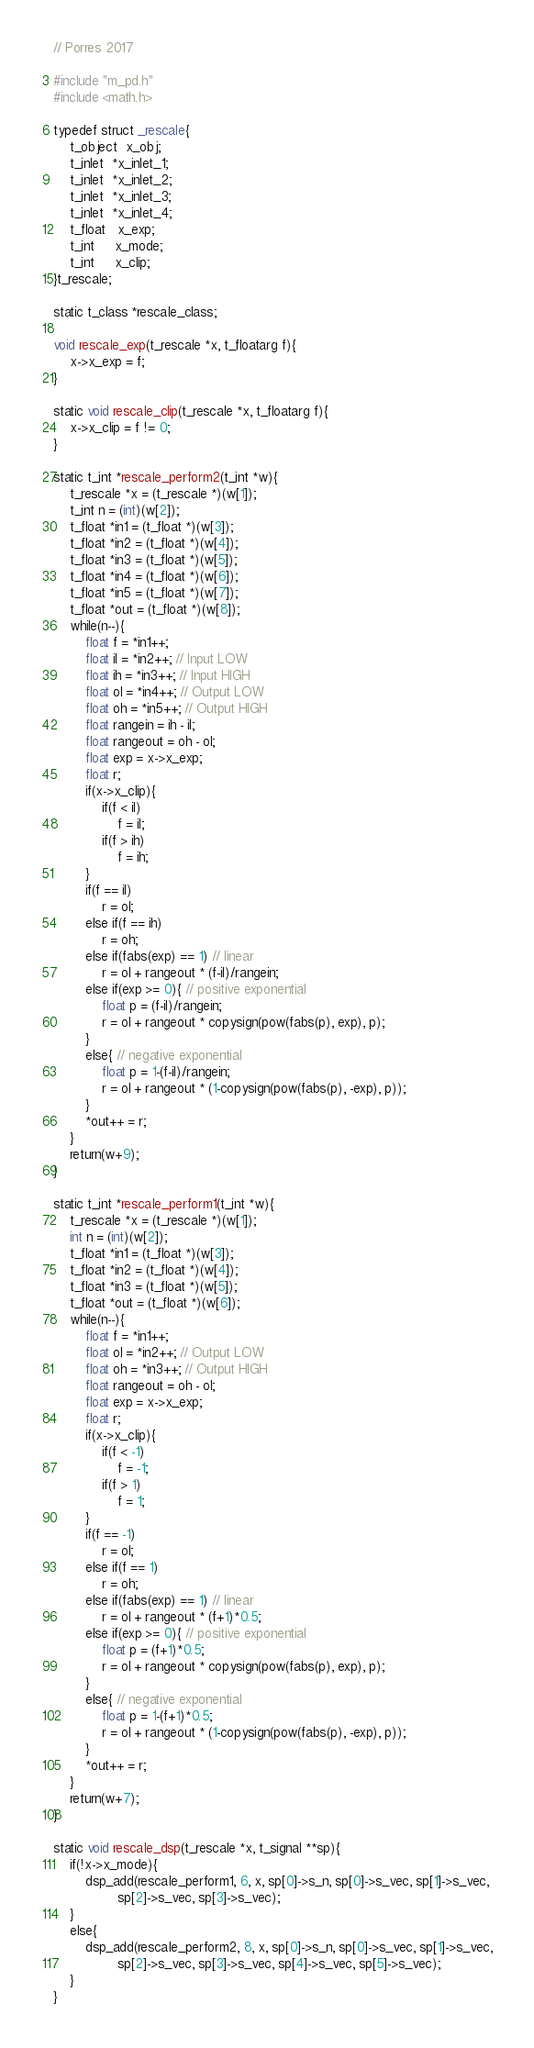Convert code to text. <code><loc_0><loc_0><loc_500><loc_500><_C_>// Porres 2017

#include "m_pd.h"
#include <math.h>

typedef struct _rescale{
    t_object  x_obj;
    t_inlet  *x_inlet_1;
    t_inlet  *x_inlet_2;
    t_inlet  *x_inlet_3;
    t_inlet  *x_inlet_4;
    t_float   x_exp;
    t_int     x_mode;
    t_int     x_clip;
}t_rescale;

static t_class *rescale_class;

void rescale_exp(t_rescale *x, t_floatarg f){
    x->x_exp = f;
}

static void rescale_clip(t_rescale *x, t_floatarg f){
    x->x_clip = f != 0;
}

static t_int *rescale_perform2(t_int *w){
    t_rescale *x = (t_rescale *)(w[1]);
    t_int n = (int)(w[2]);
    t_float *in1 = (t_float *)(w[3]);
    t_float *in2 = (t_float *)(w[4]);
    t_float *in3 = (t_float *)(w[5]);
    t_float *in4 = (t_float *)(w[6]);
    t_float *in5 = (t_float *)(w[7]);
    t_float *out = (t_float *)(w[8]);
    while(n--){
        float f = *in1++;
        float il = *in2++; // Input LOW
        float ih = *in3++; // Input HIGH
        float ol = *in4++; // Output LOW
        float oh = *in5++; // Output HIGH
        float rangein = ih - il;
        float rangeout = oh - ol;
        float exp = x->x_exp;
        float r;
        if(x->x_clip){
            if(f < il)
                f = il;
            if(f > ih)
                f = ih;
        }
        if(f == il)
            r = ol;
        else if(f == ih)
            r = oh;
        else if(fabs(exp) == 1) // linear
            r = ol + rangeout * (f-il)/rangein;
        else if(exp >= 0){ // positive exponential
            float p = (f-il)/rangein;
            r = ol + rangeout * copysign(pow(fabs(p), exp), p);
        }
        else{ // negative exponential
            float p = 1-(f-il)/rangein;
            r = ol + rangeout * (1-copysign(pow(fabs(p), -exp), p));
        }
        *out++ = r;
    }
    return(w+9);
}

static t_int *rescale_perform1(t_int *w){
    t_rescale *x = (t_rescale *)(w[1]);
    int n = (int)(w[2]);
    t_float *in1 = (t_float *)(w[3]);
    t_float *in2 = (t_float *)(w[4]);
    t_float *in3 = (t_float *)(w[5]);
    t_float *out = (t_float *)(w[6]);
    while(n--){
        float f = *in1++;
        float ol = *in2++; // Output LOW
        float oh = *in3++; // Output HIGH
        float rangeout = oh - ol;
        float exp = x->x_exp;
        float r;
        if(x->x_clip){
            if(f < -1)
                f = -1;
            if(f > 1)
                f = 1;
        }
        if(f == -1)
            r = ol;
        else if(f == 1)
            r = oh;
        else if(fabs(exp) == 1) // linear
            r = ol + rangeout * (f+1)*0.5;
        else if(exp >= 0){ // positive exponential
            float p = (f+1)*0.5;
            r = ol + rangeout * copysign(pow(fabs(p), exp), p);
        }
        else{ // negative exponential
            float p = 1-(f+1)*0.5;
            r = ol + rangeout * (1-copysign(pow(fabs(p), -exp), p));
        }
        *out++ = r;
    }
    return(w+7);
}

static void rescale_dsp(t_rescale *x, t_signal **sp){
    if(!x->x_mode){
        dsp_add(rescale_perform1, 6, x, sp[0]->s_n, sp[0]->s_vec, sp[1]->s_vec,
                sp[2]->s_vec, sp[3]->s_vec);
    }
    else{
        dsp_add(rescale_perform2, 8, x, sp[0]->s_n, sp[0]->s_vec, sp[1]->s_vec,
                sp[2]->s_vec, sp[3]->s_vec, sp[4]->s_vec, sp[5]->s_vec);
    }
}
</code> 